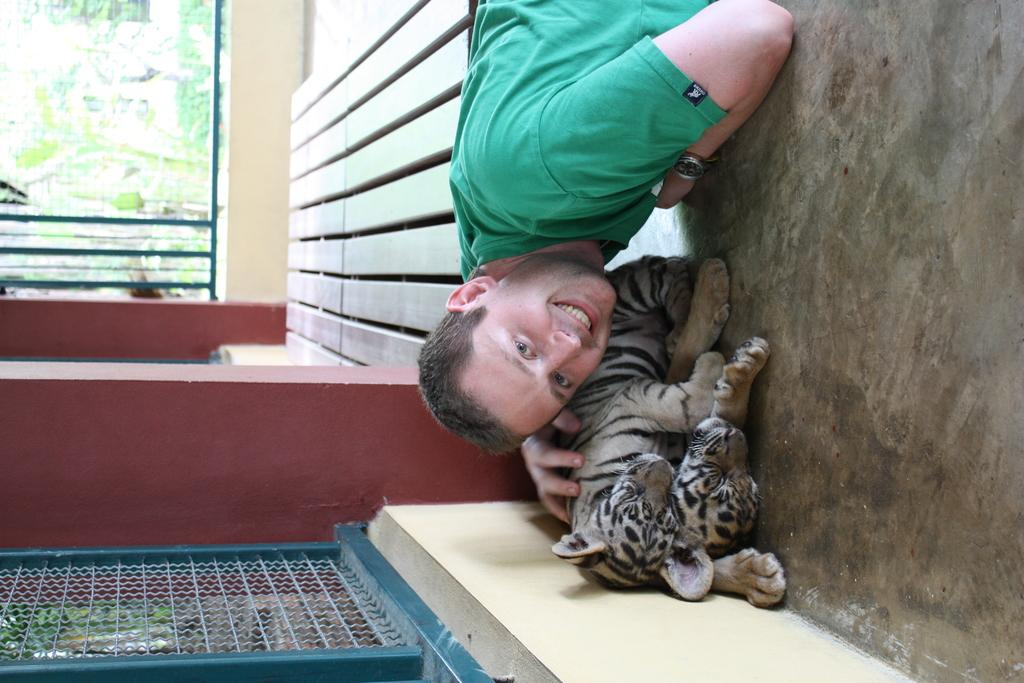Who is present in the image? There is a man in the image. What animals are in the image? There are tiger cubs in the image. What type of vegetation is in the image? There are plants in the image. What type of barrier is in the image? There is a metal fence in the image. What additional metal objects are in the image? There are metal rods in the image. How many pages does the man have in the image? There are no pages or books present in the image, so it is not possible to determine the number of pages. 